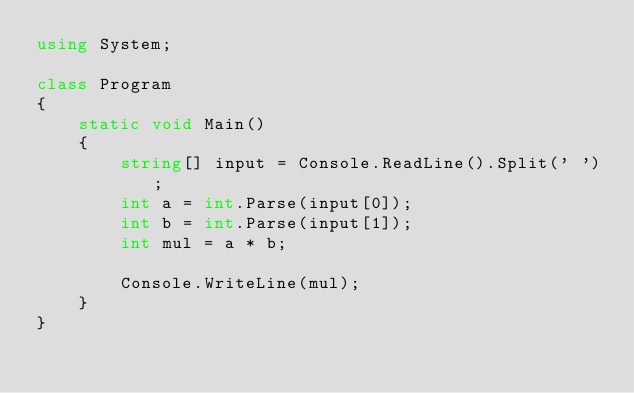Convert code to text. <code><loc_0><loc_0><loc_500><loc_500><_C#_>using System;

class Program
{
    static void Main()
    {
        string[] input = Console.ReadLine().Split(' ');
        int a = int.Parse(input[0]);
        int b = int.Parse(input[1]);
        int mul = a * b;

        Console.WriteLine(mul);
    }
}</code> 